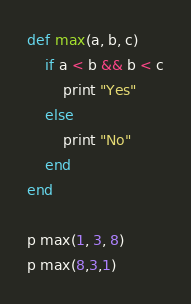Convert code to text. <code><loc_0><loc_0><loc_500><loc_500><_Ruby_>def max(a, b, c)
    if a < b && b < c
        print "Yes"
    else
        print "No"
    end
end

p max(1, 3, 8)
p max(8,3,1)
</code> 